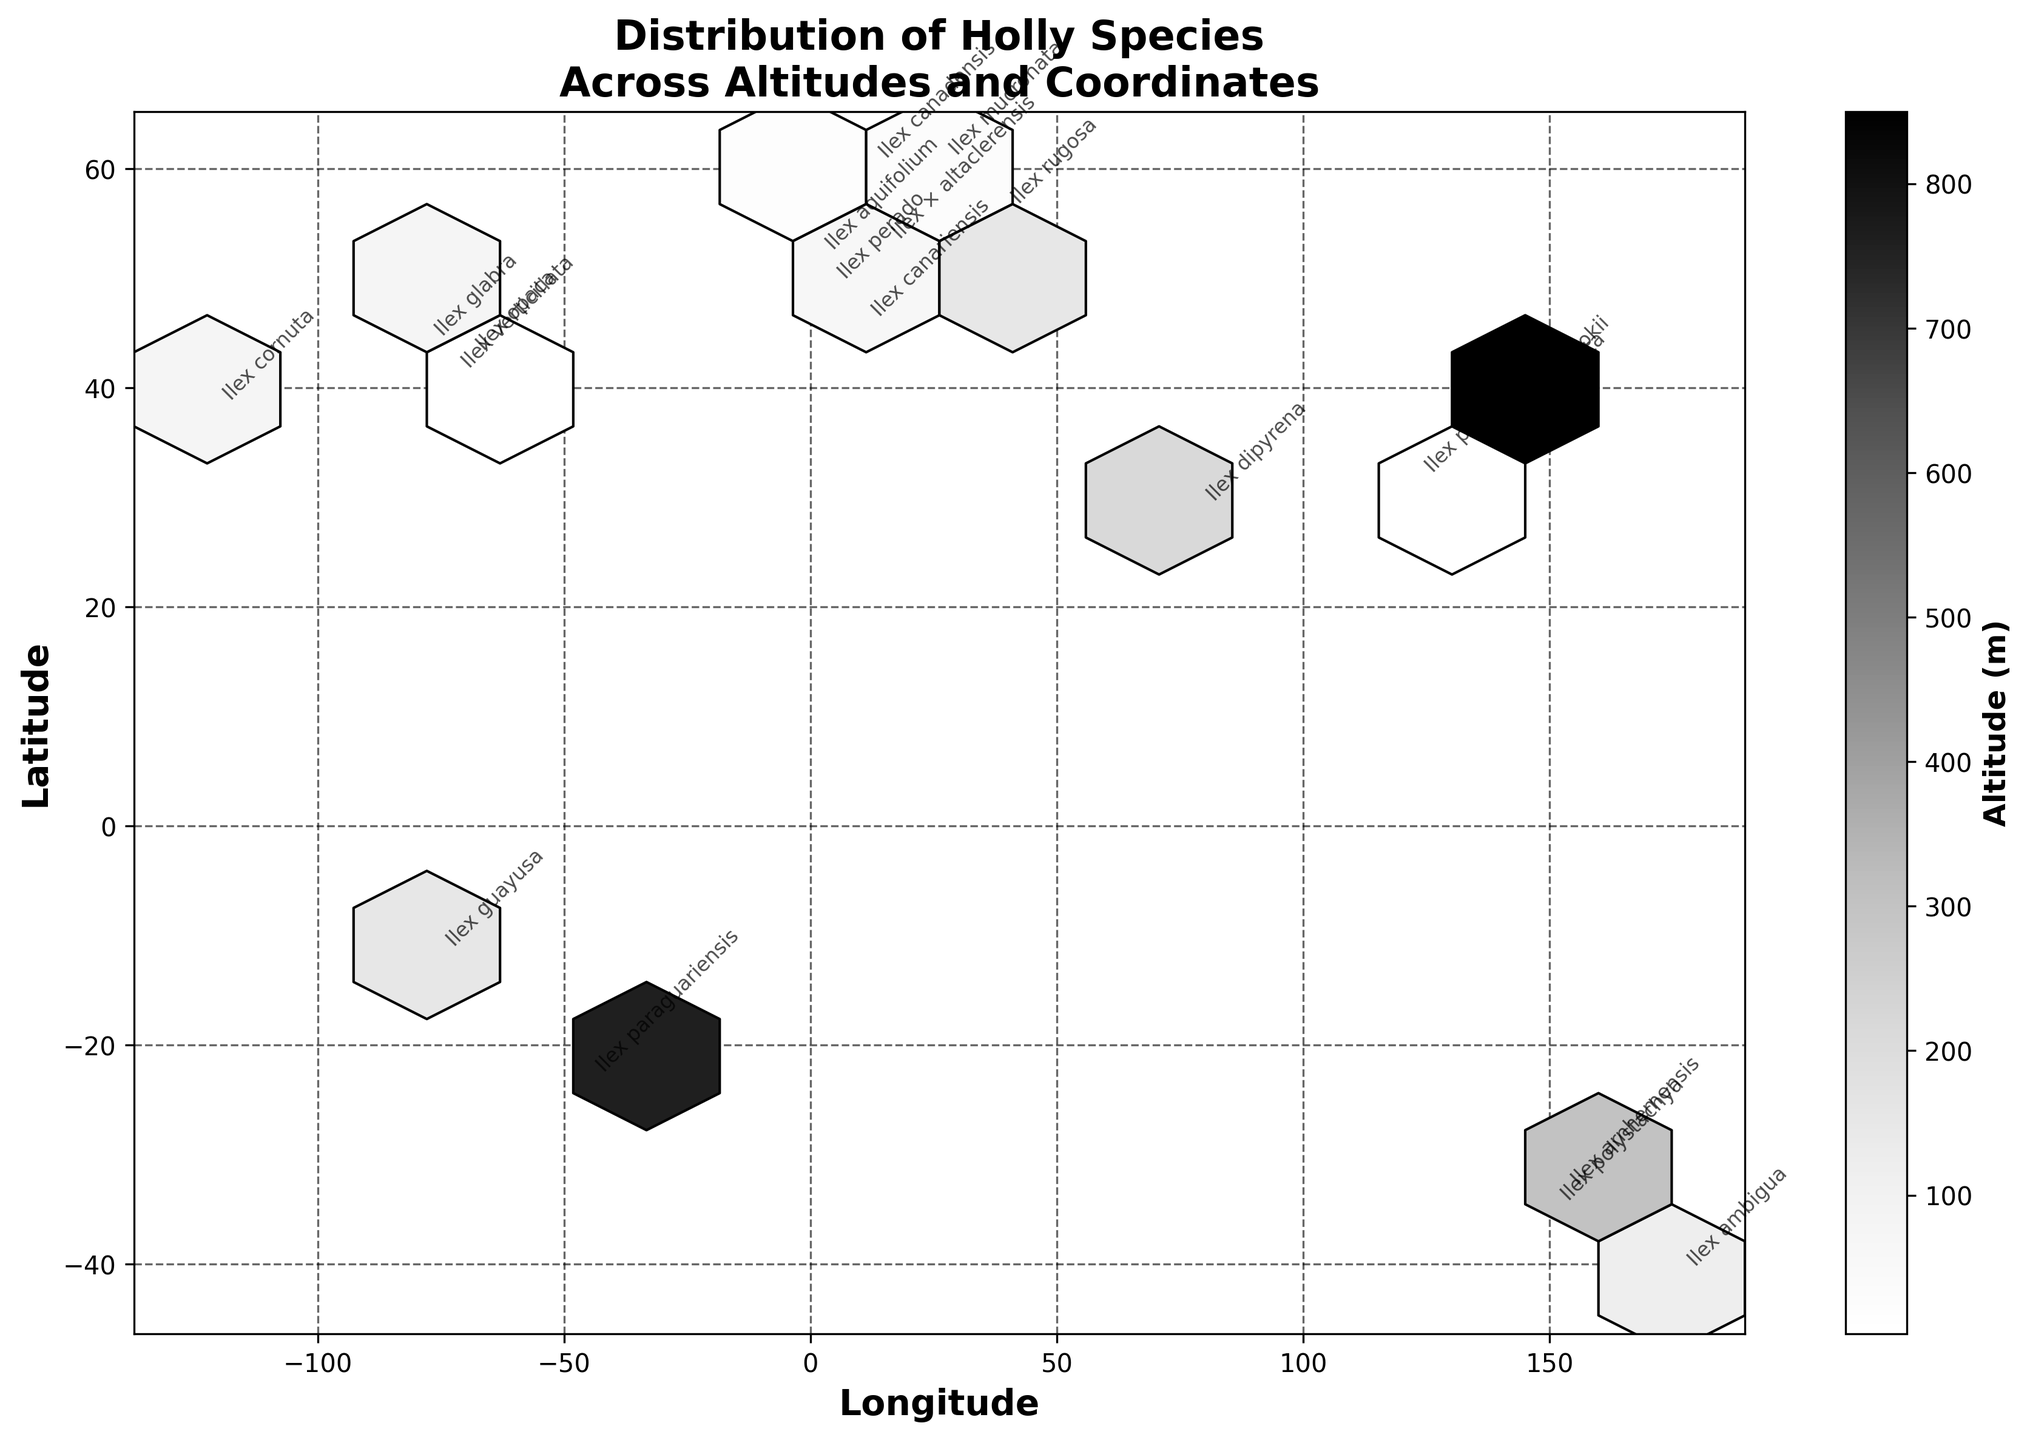What's the title of the figure? The title is typically positioned at the top of the figure in bold text. It summarizes the main theme or topic of the visualization.
Answer: Distribution of Holly Species Across Altitudes and Coordinates What does the color intensity on the hexagons represent? The figure legend (color bar) often uses a label to indicate what the color intensity represents. In this case, it is the "Altitude (m)" of the holly species.
Answer: Altitude What are the labels of the x and y axes? You can identify the labels by looking at the end of the axes which describe what they represent. The x-axis represents "Longitude" and the y-axis represents "Latitude."
Answer: Longitude and Latitude Which holly species is located at the highest altitude? By observing the annotations next to data points in the plot and referring to the color intensity, Ilex sugerokii is located at latitude 36.2048 and appears in the darkest bin, representing the highest altitude.
Answer: Ilex sugerokii Which species are found near the lowest altitude and where are they located? Looking for species annotated in the lightest hexagons near the bottom of the color bar, Ilex verticillata and Ilex pubescens appear closest to sea level. They are at latitudes 40.7128, -74.0060 and 31.2304, 121.4737 respectively.
Answer: Ilex verticillata and Ilex pubescens How are the holly species distributed geographically in terms of latitude? Analyzing the spread of annotated species along the y-axis (Latitude), the species are quite globally distributed spanning from around -41 (Southern Hemisphere) to 60 degrees (Northern Hemisphere).
Answer: Distributed from around -41 to 60 degrees latitude Do species appear clustered in certain longitude or latitude ranges? By examining the concentration of hexagons on the figure, species annotations appear densely packed around longitudes from -80 to 150 degrees and latitudes from -40 to 60 degrees, indicating clustering in these ranges.
Answer: Yes, from longitudes -80 to 150 degrees and latitudes -40 to 60 degrees Which Holly species are found at both extremes of the Western Hemisphere in terms of longitude? Considering the extremities along the x-axis and checking the annotations, Ilex cambodiana (Longitude -149.1300) and Ilex aquifolium (Longitude -0.1278) mark the extremities.
Answer: Ilex polystachya and Ilex aquifolium What is the average altitude of all the observed species? By identifying altitudes from the dataset and summing them up, then dividing by number of data points (113 + 2 + 30 + 35 + 5 + 130 + 80 + 150 + 760 + 122 + 577 + 216 + 154 + 34 + 25 + 76 + 1500+ 120 + 23 + 4), the average comes to approximately 1553/20 = 77.65 meters.
Answer: 77.65 meters 